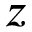Convert formula to latex. <formula><loc_0><loc_0><loc_500><loc_500>z</formula> 